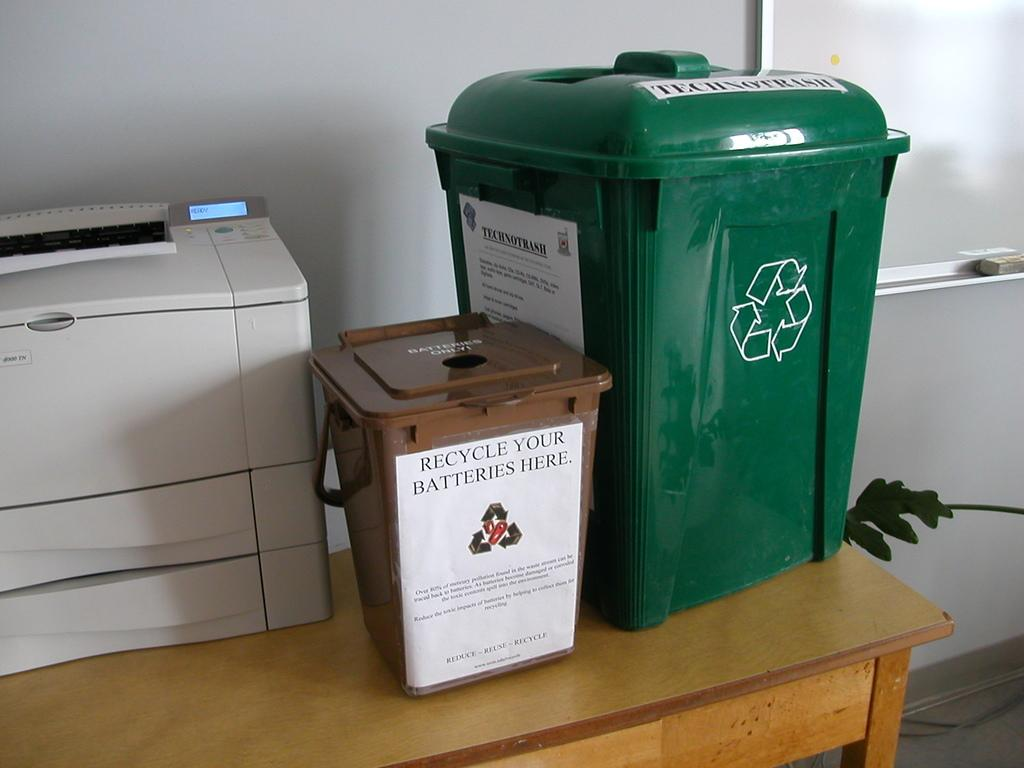Provide a one-sentence caption for the provided image. a recycle your batteries sign on a bin. 